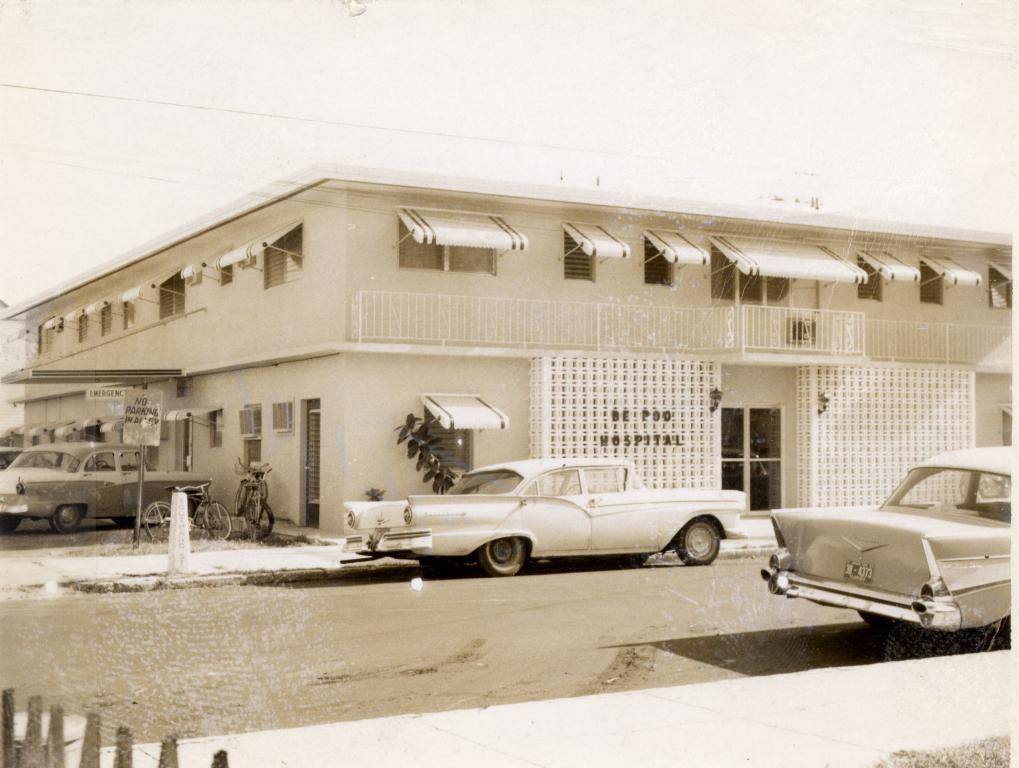What is the color scheme of the image? The image is black and white. What can be seen on the road in the image? There is a car parked on the road in the image. What type of structure is visible in the image? There is a house in the image. How many geese are flying over the house in the image? There are no geese present in the image; it is a black and white image featuring a car parked on the road and a house. 